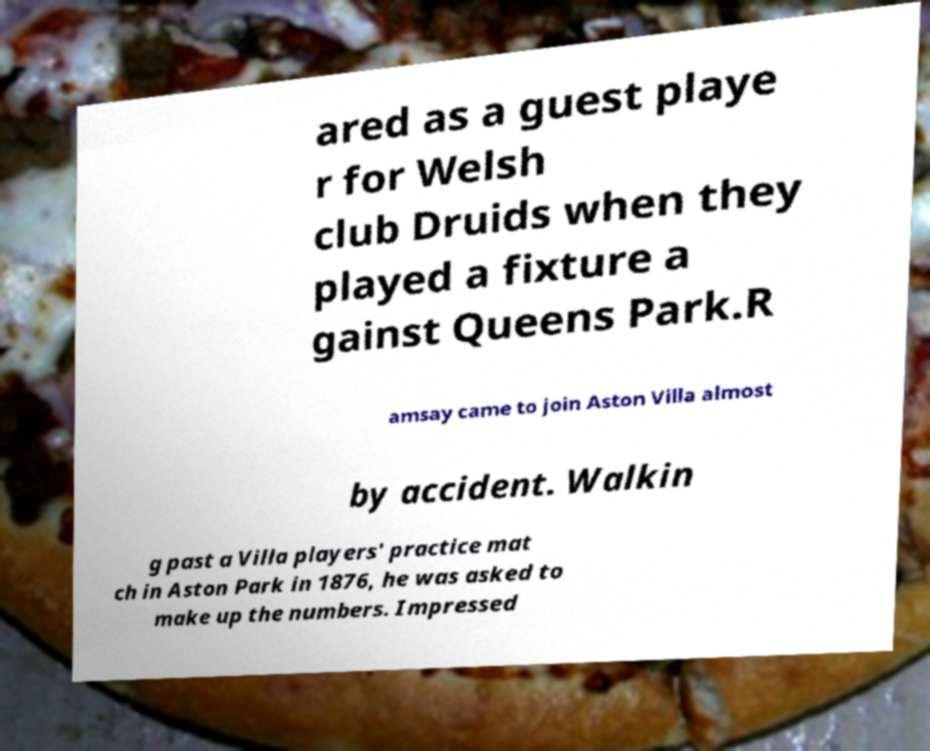What messages or text are displayed in this image? I need them in a readable, typed format. ared as a guest playe r for Welsh club Druids when they played a fixture a gainst Queens Park.R amsay came to join Aston Villa almost by accident. Walkin g past a Villa players' practice mat ch in Aston Park in 1876, he was asked to make up the numbers. Impressed 